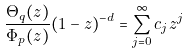Convert formula to latex. <formula><loc_0><loc_0><loc_500><loc_500>\frac { \Theta _ { q } ( z ) } { \Phi _ { p } ( z ) } ( 1 - z ) ^ { - d } = \sum _ { j = 0 } ^ { \infty } c _ { j } z ^ { j }</formula> 